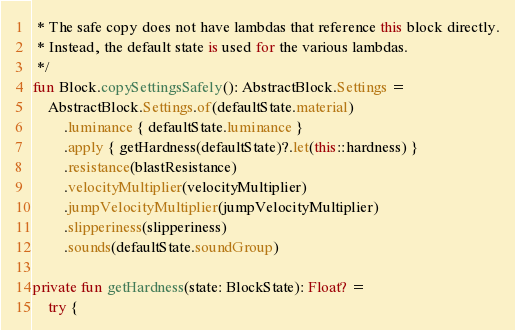<code> <loc_0><loc_0><loc_500><loc_500><_Kotlin_> * The safe copy does not have lambdas that reference this block directly.
 * Instead, the default state is used for the various lambdas.
 */
fun Block.copySettingsSafely(): AbstractBlock.Settings =
    AbstractBlock.Settings.of(defaultState.material)
        .luminance { defaultState.luminance }
        .apply { getHardness(defaultState)?.let(this::hardness) }
        .resistance(blastResistance)
        .velocityMultiplier(velocityMultiplier)
        .jumpVelocityMultiplier(jumpVelocityMultiplier)
        .slipperiness(slipperiness)
        .sounds(defaultState.soundGroup)

private fun getHardness(state: BlockState): Float? =
    try {</code> 